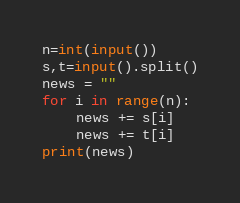Convert code to text. <code><loc_0><loc_0><loc_500><loc_500><_Python_>n=int(input())
s,t=input().split()
news = ""
for i in range(n):
	news += s[i]
	news += t[i]
print(news)</code> 